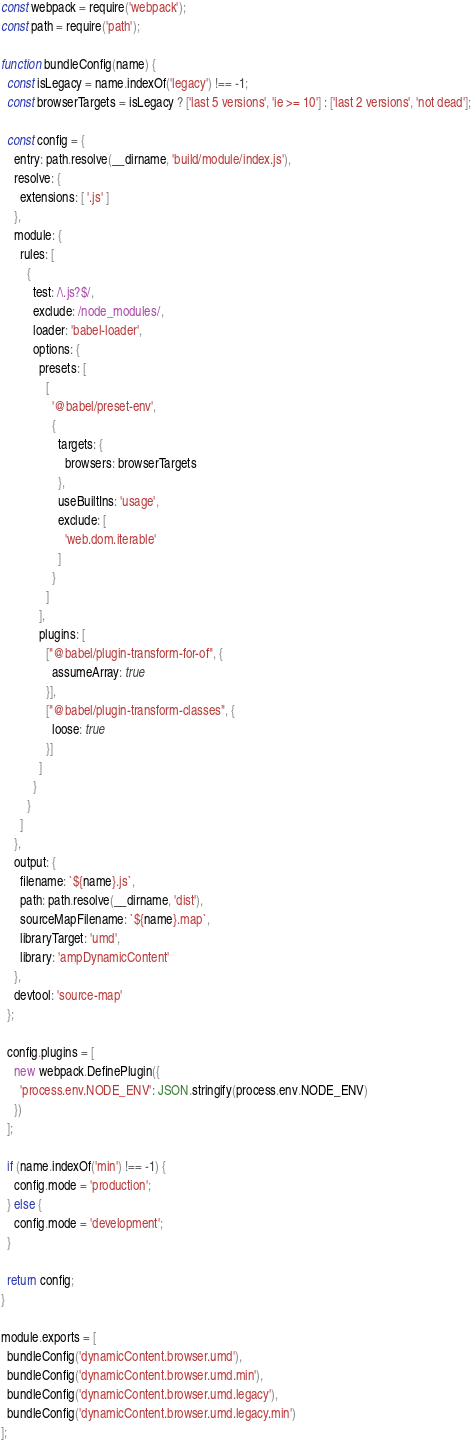Convert code to text. <code><loc_0><loc_0><loc_500><loc_500><_JavaScript_>const webpack = require('webpack');
const path = require('path');

function bundleConfig(name) {
  const isLegacy = name.indexOf('legacy') !== -1;
  const browserTargets = isLegacy ? ['last 5 versions', 'ie >= 10'] : ['last 2 versions', 'not dead'];
  
  const config = {
    entry: path.resolve(__dirname, 'build/module/index.js'),
    resolve: {
      extensions: [ '.js' ]
    },
    module: {
      rules: [
        {
          test: /\.js?$/,
          exclude: /node_modules/,
          loader: 'babel-loader',
          options: {
            presets: [
              [
                '@babel/preset-env', 
                {
                  targets: {
                    browsers: browserTargets
                  },
                  useBuiltIns: 'usage',
                  exclude: [
                    'web.dom.iterable'
                  ]
                }
              ]
            ],
            plugins: [
              ["@babel/plugin-transform-for-of", {
                assumeArray: true
              }],
              ["@babel/plugin-transform-classes", {
                loose: true
              }]
            ]
          }
        }
      ]
    },
    output: {
      filename: `${name}.js`,
      path: path.resolve(__dirname, 'dist'),
      sourceMapFilename: `${name}.map`,
      libraryTarget: 'umd',
      library: 'ampDynamicContent'
    },
    devtool: 'source-map'
  };

  config.plugins = [
    new webpack.DefinePlugin({
      'process.env.NODE_ENV': JSON.stringify(process.env.NODE_ENV)
    })
  ];
  
  if (name.indexOf('min') !== -1) {
    config.mode = 'production';
  } else {
    config.mode = 'development';
  }

  return config;
}

module.exports = [
  bundleConfig('dynamicContent.browser.umd'),
  bundleConfig('dynamicContent.browser.umd.min'),
  bundleConfig('dynamicContent.browser.umd.legacy'),
  bundleConfig('dynamicContent.browser.umd.legacy.min')
];</code> 